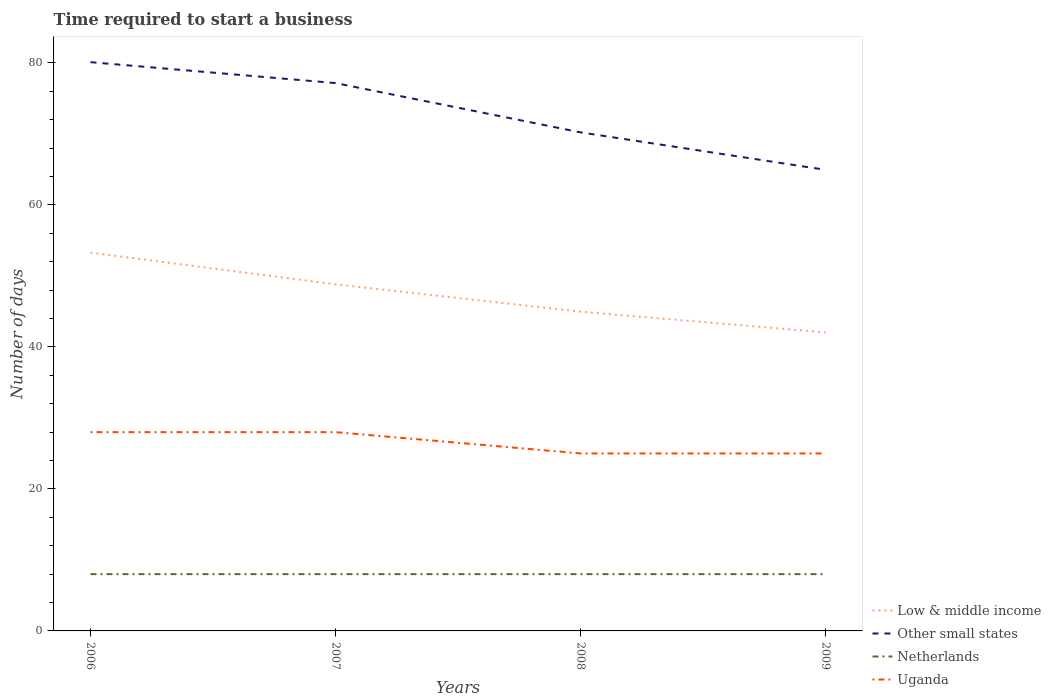Across all years, what is the maximum number of days required to start a business in Other small states?
Your answer should be compact. 64.94. In which year was the number of days required to start a business in Low & middle income maximum?
Provide a succinct answer. 2009. What is the difference between the highest and the lowest number of days required to start a business in Low & middle income?
Make the answer very short. 2. Is the number of days required to start a business in Uganda strictly greater than the number of days required to start a business in Netherlands over the years?
Provide a short and direct response. No. How many lines are there?
Keep it short and to the point. 4. What is the difference between two consecutive major ticks on the Y-axis?
Give a very brief answer. 20. Does the graph contain any zero values?
Provide a short and direct response. No. Does the graph contain grids?
Your response must be concise. No. How many legend labels are there?
Provide a succinct answer. 4. What is the title of the graph?
Provide a short and direct response. Time required to start a business. What is the label or title of the Y-axis?
Your answer should be compact. Number of days. What is the Number of days in Low & middle income in 2006?
Make the answer very short. 53.28. What is the Number of days in Other small states in 2006?
Your response must be concise. 80.11. What is the Number of days of Low & middle income in 2007?
Make the answer very short. 48.82. What is the Number of days of Other small states in 2007?
Your answer should be compact. 77.17. What is the Number of days of Netherlands in 2007?
Your response must be concise. 8. What is the Number of days of Low & middle income in 2008?
Offer a very short reply. 44.97. What is the Number of days of Other small states in 2008?
Offer a terse response. 70.22. What is the Number of days in Uganda in 2008?
Provide a succinct answer. 25. What is the Number of days in Low & middle income in 2009?
Your answer should be compact. 42.05. What is the Number of days in Other small states in 2009?
Make the answer very short. 64.94. Across all years, what is the maximum Number of days of Low & middle income?
Your response must be concise. 53.28. Across all years, what is the maximum Number of days in Other small states?
Keep it short and to the point. 80.11. Across all years, what is the minimum Number of days of Low & middle income?
Your answer should be very brief. 42.05. Across all years, what is the minimum Number of days in Other small states?
Offer a terse response. 64.94. Across all years, what is the minimum Number of days in Netherlands?
Your answer should be compact. 8. What is the total Number of days in Low & middle income in the graph?
Provide a succinct answer. 189.12. What is the total Number of days in Other small states in the graph?
Your response must be concise. 292.44. What is the total Number of days in Uganda in the graph?
Make the answer very short. 106. What is the difference between the Number of days in Low & middle income in 2006 and that in 2007?
Give a very brief answer. 4.46. What is the difference between the Number of days of Other small states in 2006 and that in 2007?
Ensure brevity in your answer.  2.94. What is the difference between the Number of days in Low & middle income in 2006 and that in 2008?
Your answer should be compact. 8.32. What is the difference between the Number of days of Other small states in 2006 and that in 2008?
Make the answer very short. 9.89. What is the difference between the Number of days in Netherlands in 2006 and that in 2008?
Offer a very short reply. 0. What is the difference between the Number of days of Uganda in 2006 and that in 2008?
Offer a very short reply. 3. What is the difference between the Number of days in Low & middle income in 2006 and that in 2009?
Give a very brief answer. 11.24. What is the difference between the Number of days of Other small states in 2006 and that in 2009?
Offer a very short reply. 15.17. What is the difference between the Number of days in Netherlands in 2006 and that in 2009?
Offer a very short reply. 0. What is the difference between the Number of days in Uganda in 2006 and that in 2009?
Offer a terse response. 3. What is the difference between the Number of days in Low & middle income in 2007 and that in 2008?
Give a very brief answer. 3.86. What is the difference between the Number of days of Other small states in 2007 and that in 2008?
Make the answer very short. 6.94. What is the difference between the Number of days of Netherlands in 2007 and that in 2008?
Provide a succinct answer. 0. What is the difference between the Number of days of Uganda in 2007 and that in 2008?
Keep it short and to the point. 3. What is the difference between the Number of days in Low & middle income in 2007 and that in 2009?
Offer a terse response. 6.78. What is the difference between the Number of days in Other small states in 2007 and that in 2009?
Give a very brief answer. 12.22. What is the difference between the Number of days of Netherlands in 2007 and that in 2009?
Give a very brief answer. 0. What is the difference between the Number of days in Uganda in 2007 and that in 2009?
Your answer should be very brief. 3. What is the difference between the Number of days in Low & middle income in 2008 and that in 2009?
Make the answer very short. 2.92. What is the difference between the Number of days in Other small states in 2008 and that in 2009?
Keep it short and to the point. 5.28. What is the difference between the Number of days in Uganda in 2008 and that in 2009?
Offer a very short reply. 0. What is the difference between the Number of days in Low & middle income in 2006 and the Number of days in Other small states in 2007?
Your response must be concise. -23.88. What is the difference between the Number of days in Low & middle income in 2006 and the Number of days in Netherlands in 2007?
Provide a succinct answer. 45.28. What is the difference between the Number of days of Low & middle income in 2006 and the Number of days of Uganda in 2007?
Your response must be concise. 25.28. What is the difference between the Number of days of Other small states in 2006 and the Number of days of Netherlands in 2007?
Offer a terse response. 72.11. What is the difference between the Number of days of Other small states in 2006 and the Number of days of Uganda in 2007?
Make the answer very short. 52.11. What is the difference between the Number of days in Low & middle income in 2006 and the Number of days in Other small states in 2008?
Offer a terse response. -16.94. What is the difference between the Number of days of Low & middle income in 2006 and the Number of days of Netherlands in 2008?
Make the answer very short. 45.28. What is the difference between the Number of days in Low & middle income in 2006 and the Number of days in Uganda in 2008?
Provide a short and direct response. 28.28. What is the difference between the Number of days in Other small states in 2006 and the Number of days in Netherlands in 2008?
Make the answer very short. 72.11. What is the difference between the Number of days in Other small states in 2006 and the Number of days in Uganda in 2008?
Your answer should be very brief. 55.11. What is the difference between the Number of days of Netherlands in 2006 and the Number of days of Uganda in 2008?
Provide a short and direct response. -17. What is the difference between the Number of days of Low & middle income in 2006 and the Number of days of Other small states in 2009?
Offer a terse response. -11.66. What is the difference between the Number of days in Low & middle income in 2006 and the Number of days in Netherlands in 2009?
Make the answer very short. 45.28. What is the difference between the Number of days of Low & middle income in 2006 and the Number of days of Uganda in 2009?
Offer a terse response. 28.28. What is the difference between the Number of days in Other small states in 2006 and the Number of days in Netherlands in 2009?
Give a very brief answer. 72.11. What is the difference between the Number of days of Other small states in 2006 and the Number of days of Uganda in 2009?
Your response must be concise. 55.11. What is the difference between the Number of days of Low & middle income in 2007 and the Number of days of Other small states in 2008?
Keep it short and to the point. -21.4. What is the difference between the Number of days in Low & middle income in 2007 and the Number of days in Netherlands in 2008?
Keep it short and to the point. 40.82. What is the difference between the Number of days of Low & middle income in 2007 and the Number of days of Uganda in 2008?
Your answer should be very brief. 23.82. What is the difference between the Number of days of Other small states in 2007 and the Number of days of Netherlands in 2008?
Provide a short and direct response. 69.17. What is the difference between the Number of days in Other small states in 2007 and the Number of days in Uganda in 2008?
Your answer should be very brief. 52.17. What is the difference between the Number of days in Low & middle income in 2007 and the Number of days in Other small states in 2009?
Give a very brief answer. -16.12. What is the difference between the Number of days of Low & middle income in 2007 and the Number of days of Netherlands in 2009?
Your response must be concise. 40.82. What is the difference between the Number of days in Low & middle income in 2007 and the Number of days in Uganda in 2009?
Ensure brevity in your answer.  23.82. What is the difference between the Number of days in Other small states in 2007 and the Number of days in Netherlands in 2009?
Provide a short and direct response. 69.17. What is the difference between the Number of days in Other small states in 2007 and the Number of days in Uganda in 2009?
Keep it short and to the point. 52.17. What is the difference between the Number of days of Netherlands in 2007 and the Number of days of Uganda in 2009?
Make the answer very short. -17. What is the difference between the Number of days of Low & middle income in 2008 and the Number of days of Other small states in 2009?
Provide a succinct answer. -19.98. What is the difference between the Number of days of Low & middle income in 2008 and the Number of days of Netherlands in 2009?
Offer a terse response. 36.97. What is the difference between the Number of days of Low & middle income in 2008 and the Number of days of Uganda in 2009?
Your answer should be compact. 19.97. What is the difference between the Number of days of Other small states in 2008 and the Number of days of Netherlands in 2009?
Your response must be concise. 62.22. What is the difference between the Number of days in Other small states in 2008 and the Number of days in Uganda in 2009?
Your response must be concise. 45.22. What is the difference between the Number of days of Netherlands in 2008 and the Number of days of Uganda in 2009?
Provide a short and direct response. -17. What is the average Number of days of Low & middle income per year?
Keep it short and to the point. 47.28. What is the average Number of days in Other small states per year?
Ensure brevity in your answer.  73.11. What is the average Number of days in Netherlands per year?
Your answer should be compact. 8. In the year 2006, what is the difference between the Number of days in Low & middle income and Number of days in Other small states?
Your answer should be compact. -26.83. In the year 2006, what is the difference between the Number of days of Low & middle income and Number of days of Netherlands?
Your response must be concise. 45.28. In the year 2006, what is the difference between the Number of days of Low & middle income and Number of days of Uganda?
Offer a terse response. 25.28. In the year 2006, what is the difference between the Number of days of Other small states and Number of days of Netherlands?
Your answer should be very brief. 72.11. In the year 2006, what is the difference between the Number of days in Other small states and Number of days in Uganda?
Give a very brief answer. 52.11. In the year 2007, what is the difference between the Number of days of Low & middle income and Number of days of Other small states?
Ensure brevity in your answer.  -28.34. In the year 2007, what is the difference between the Number of days of Low & middle income and Number of days of Netherlands?
Your answer should be compact. 40.82. In the year 2007, what is the difference between the Number of days in Low & middle income and Number of days in Uganda?
Offer a terse response. 20.82. In the year 2007, what is the difference between the Number of days of Other small states and Number of days of Netherlands?
Give a very brief answer. 69.17. In the year 2007, what is the difference between the Number of days in Other small states and Number of days in Uganda?
Ensure brevity in your answer.  49.17. In the year 2007, what is the difference between the Number of days of Netherlands and Number of days of Uganda?
Your answer should be very brief. -20. In the year 2008, what is the difference between the Number of days of Low & middle income and Number of days of Other small states?
Your answer should be compact. -25.26. In the year 2008, what is the difference between the Number of days of Low & middle income and Number of days of Netherlands?
Your answer should be compact. 36.97. In the year 2008, what is the difference between the Number of days in Low & middle income and Number of days in Uganda?
Provide a succinct answer. 19.97. In the year 2008, what is the difference between the Number of days of Other small states and Number of days of Netherlands?
Provide a succinct answer. 62.22. In the year 2008, what is the difference between the Number of days of Other small states and Number of days of Uganda?
Give a very brief answer. 45.22. In the year 2008, what is the difference between the Number of days in Netherlands and Number of days in Uganda?
Keep it short and to the point. -17. In the year 2009, what is the difference between the Number of days of Low & middle income and Number of days of Other small states?
Your answer should be compact. -22.9. In the year 2009, what is the difference between the Number of days in Low & middle income and Number of days in Netherlands?
Offer a terse response. 34.05. In the year 2009, what is the difference between the Number of days of Low & middle income and Number of days of Uganda?
Keep it short and to the point. 17.05. In the year 2009, what is the difference between the Number of days of Other small states and Number of days of Netherlands?
Offer a terse response. 56.94. In the year 2009, what is the difference between the Number of days of Other small states and Number of days of Uganda?
Your response must be concise. 39.94. In the year 2009, what is the difference between the Number of days in Netherlands and Number of days in Uganda?
Offer a very short reply. -17. What is the ratio of the Number of days in Low & middle income in 2006 to that in 2007?
Ensure brevity in your answer.  1.09. What is the ratio of the Number of days of Other small states in 2006 to that in 2007?
Your response must be concise. 1.04. What is the ratio of the Number of days of Low & middle income in 2006 to that in 2008?
Offer a very short reply. 1.18. What is the ratio of the Number of days of Other small states in 2006 to that in 2008?
Provide a short and direct response. 1.14. What is the ratio of the Number of days of Uganda in 2006 to that in 2008?
Keep it short and to the point. 1.12. What is the ratio of the Number of days of Low & middle income in 2006 to that in 2009?
Your response must be concise. 1.27. What is the ratio of the Number of days of Other small states in 2006 to that in 2009?
Give a very brief answer. 1.23. What is the ratio of the Number of days in Uganda in 2006 to that in 2009?
Ensure brevity in your answer.  1.12. What is the ratio of the Number of days in Low & middle income in 2007 to that in 2008?
Provide a succinct answer. 1.09. What is the ratio of the Number of days of Other small states in 2007 to that in 2008?
Provide a succinct answer. 1.1. What is the ratio of the Number of days of Uganda in 2007 to that in 2008?
Your response must be concise. 1.12. What is the ratio of the Number of days in Low & middle income in 2007 to that in 2009?
Keep it short and to the point. 1.16. What is the ratio of the Number of days in Other small states in 2007 to that in 2009?
Your answer should be compact. 1.19. What is the ratio of the Number of days in Uganda in 2007 to that in 2009?
Give a very brief answer. 1.12. What is the ratio of the Number of days of Low & middle income in 2008 to that in 2009?
Offer a very short reply. 1.07. What is the ratio of the Number of days in Other small states in 2008 to that in 2009?
Offer a very short reply. 1.08. What is the ratio of the Number of days in Uganda in 2008 to that in 2009?
Keep it short and to the point. 1. What is the difference between the highest and the second highest Number of days in Low & middle income?
Your answer should be very brief. 4.46. What is the difference between the highest and the second highest Number of days of Other small states?
Keep it short and to the point. 2.94. What is the difference between the highest and the lowest Number of days in Low & middle income?
Offer a terse response. 11.24. What is the difference between the highest and the lowest Number of days of Other small states?
Keep it short and to the point. 15.17. 